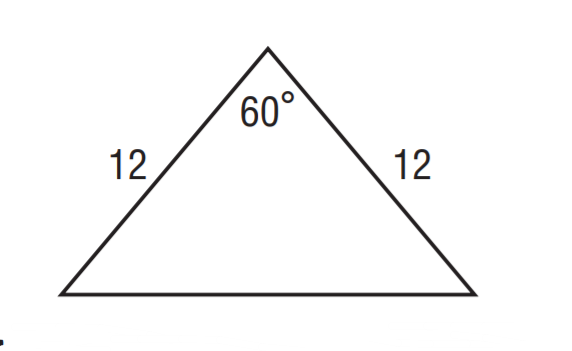Answer the mathemtical geometry problem and directly provide the correct option letter.
Question: What is the perimeter of the triangle?
Choices: A: 12 B: 24 C: 36 D: 104 C 